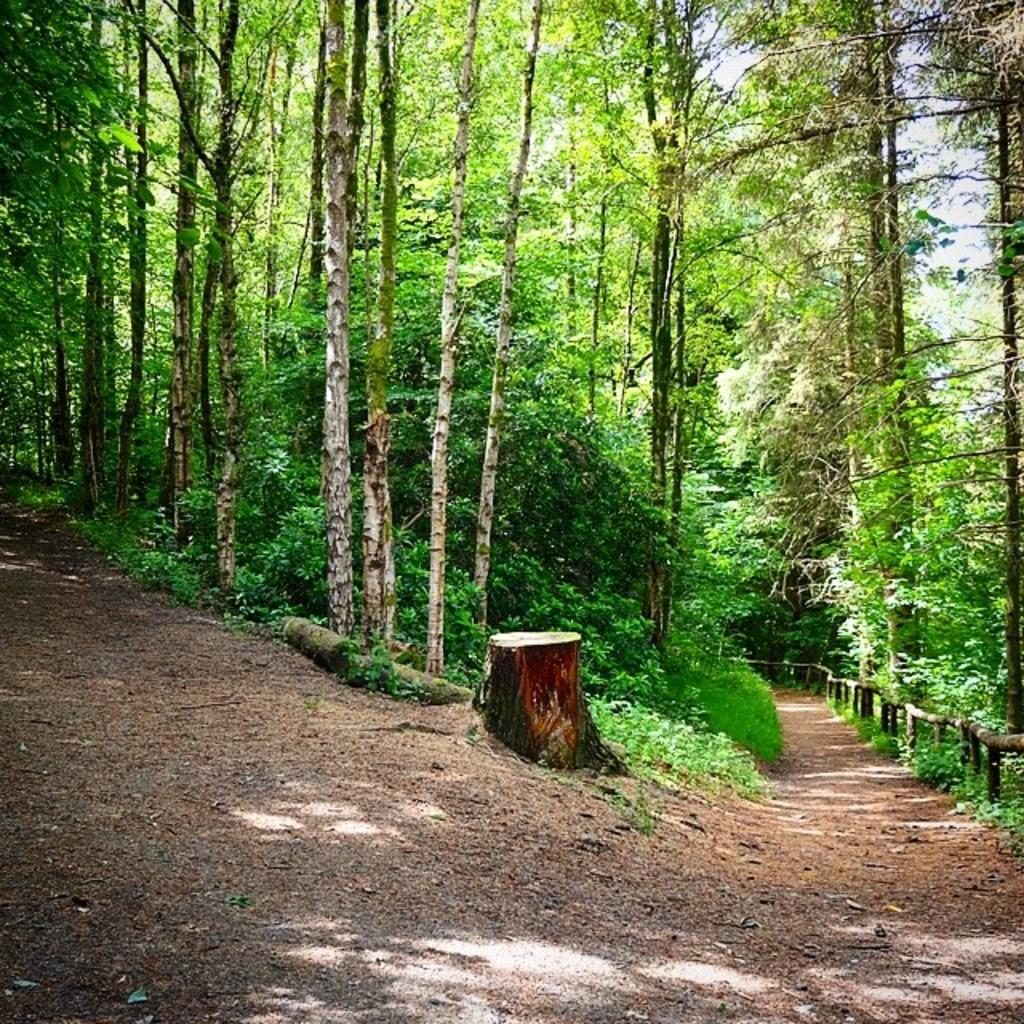What type of vegetation is present in the image? There are trees in the image. What else can be seen on the ground in the image? There are wooden logs in the image. What is visible in the background of the image? The sky is visible in the image. What type of polish is being applied to the cart in the image? There is no cart present in the image, and therefore no polish is being applied. 